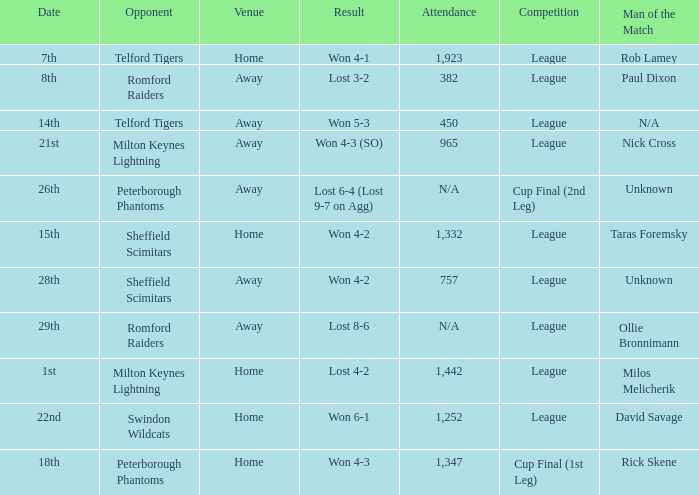What was the result on the 26th? Lost 6-4 (Lost 9-7 on Agg). 